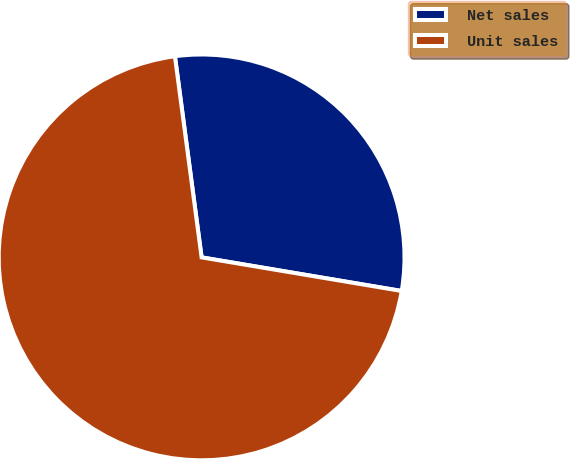Convert chart. <chart><loc_0><loc_0><loc_500><loc_500><pie_chart><fcel>Net sales<fcel>Unit sales<nl><fcel>29.75%<fcel>70.25%<nl></chart> 